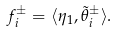<formula> <loc_0><loc_0><loc_500><loc_500>f _ { i } ^ { \pm } = \langle \eta _ { 1 } , \tilde { \theta } _ { i } ^ { \pm } \rangle .</formula> 